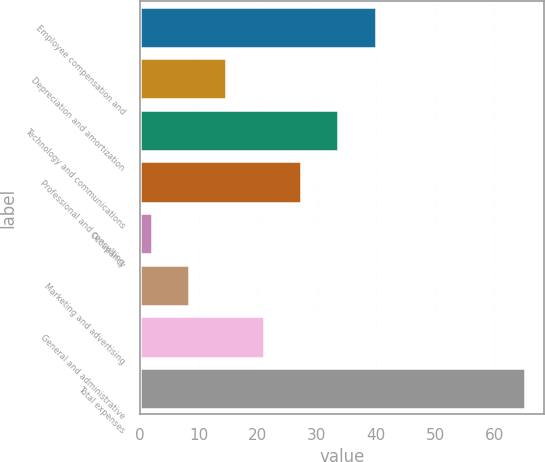<chart> <loc_0><loc_0><loc_500><loc_500><bar_chart><fcel>Employee compensation and<fcel>Depreciation and amortization<fcel>Technology and communications<fcel>Professional and consulting<fcel>Occupancy<fcel>Marketing and advertising<fcel>General and administrative<fcel>Total expenses<nl><fcel>39.92<fcel>14.64<fcel>33.6<fcel>27.28<fcel>2<fcel>8.32<fcel>20.96<fcel>65.2<nl></chart> 